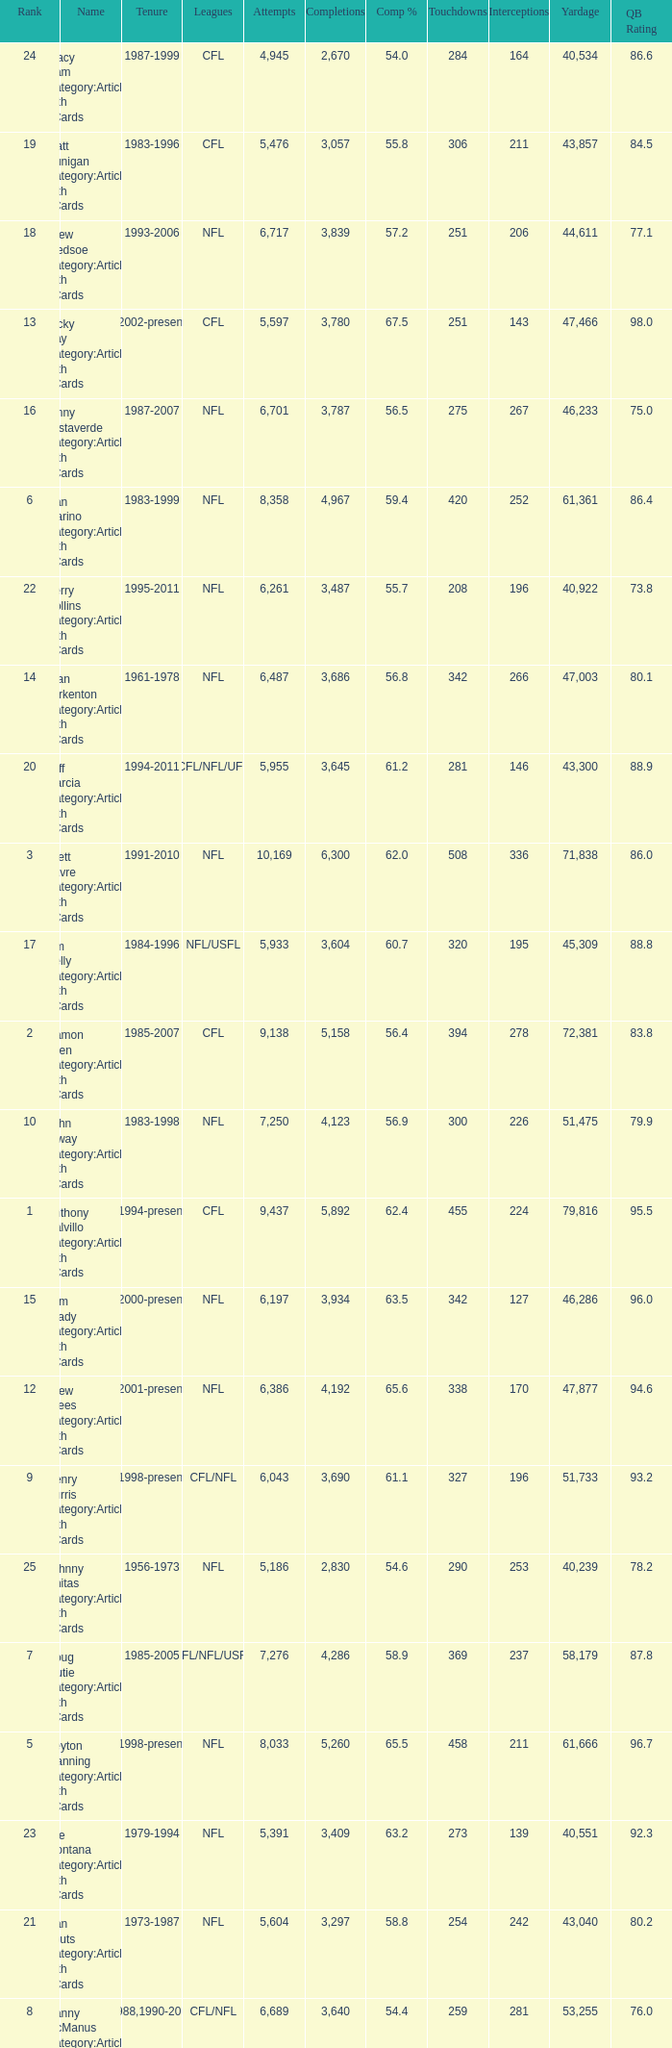What is the number of interceptions with less than 3,487 completions , more than 40,551 yardage, and the comp % is 55.8? 211.0. 